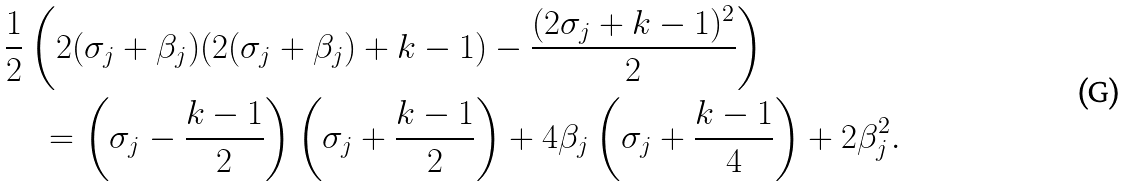Convert formula to latex. <formula><loc_0><loc_0><loc_500><loc_500>& \frac { 1 } { 2 } \left ( 2 ( \sigma _ { j } + \beta _ { j } ) ( 2 ( \sigma _ { j } + \beta _ { j } ) + k - 1 ) - \frac { ( 2 \sigma _ { j } + k - 1 ) ^ { 2 } } { 2 } \right ) \\ & \quad = \left ( \sigma _ { j } - \frac { k - 1 } { 2 } \right ) \left ( \sigma _ { j } + \frac { k - 1 } { 2 } \right ) + 4 \beta _ { j } \left ( \sigma _ { j } + \frac { k - 1 } { 4 } \right ) + 2 \beta _ { j } ^ { 2 } .</formula> 